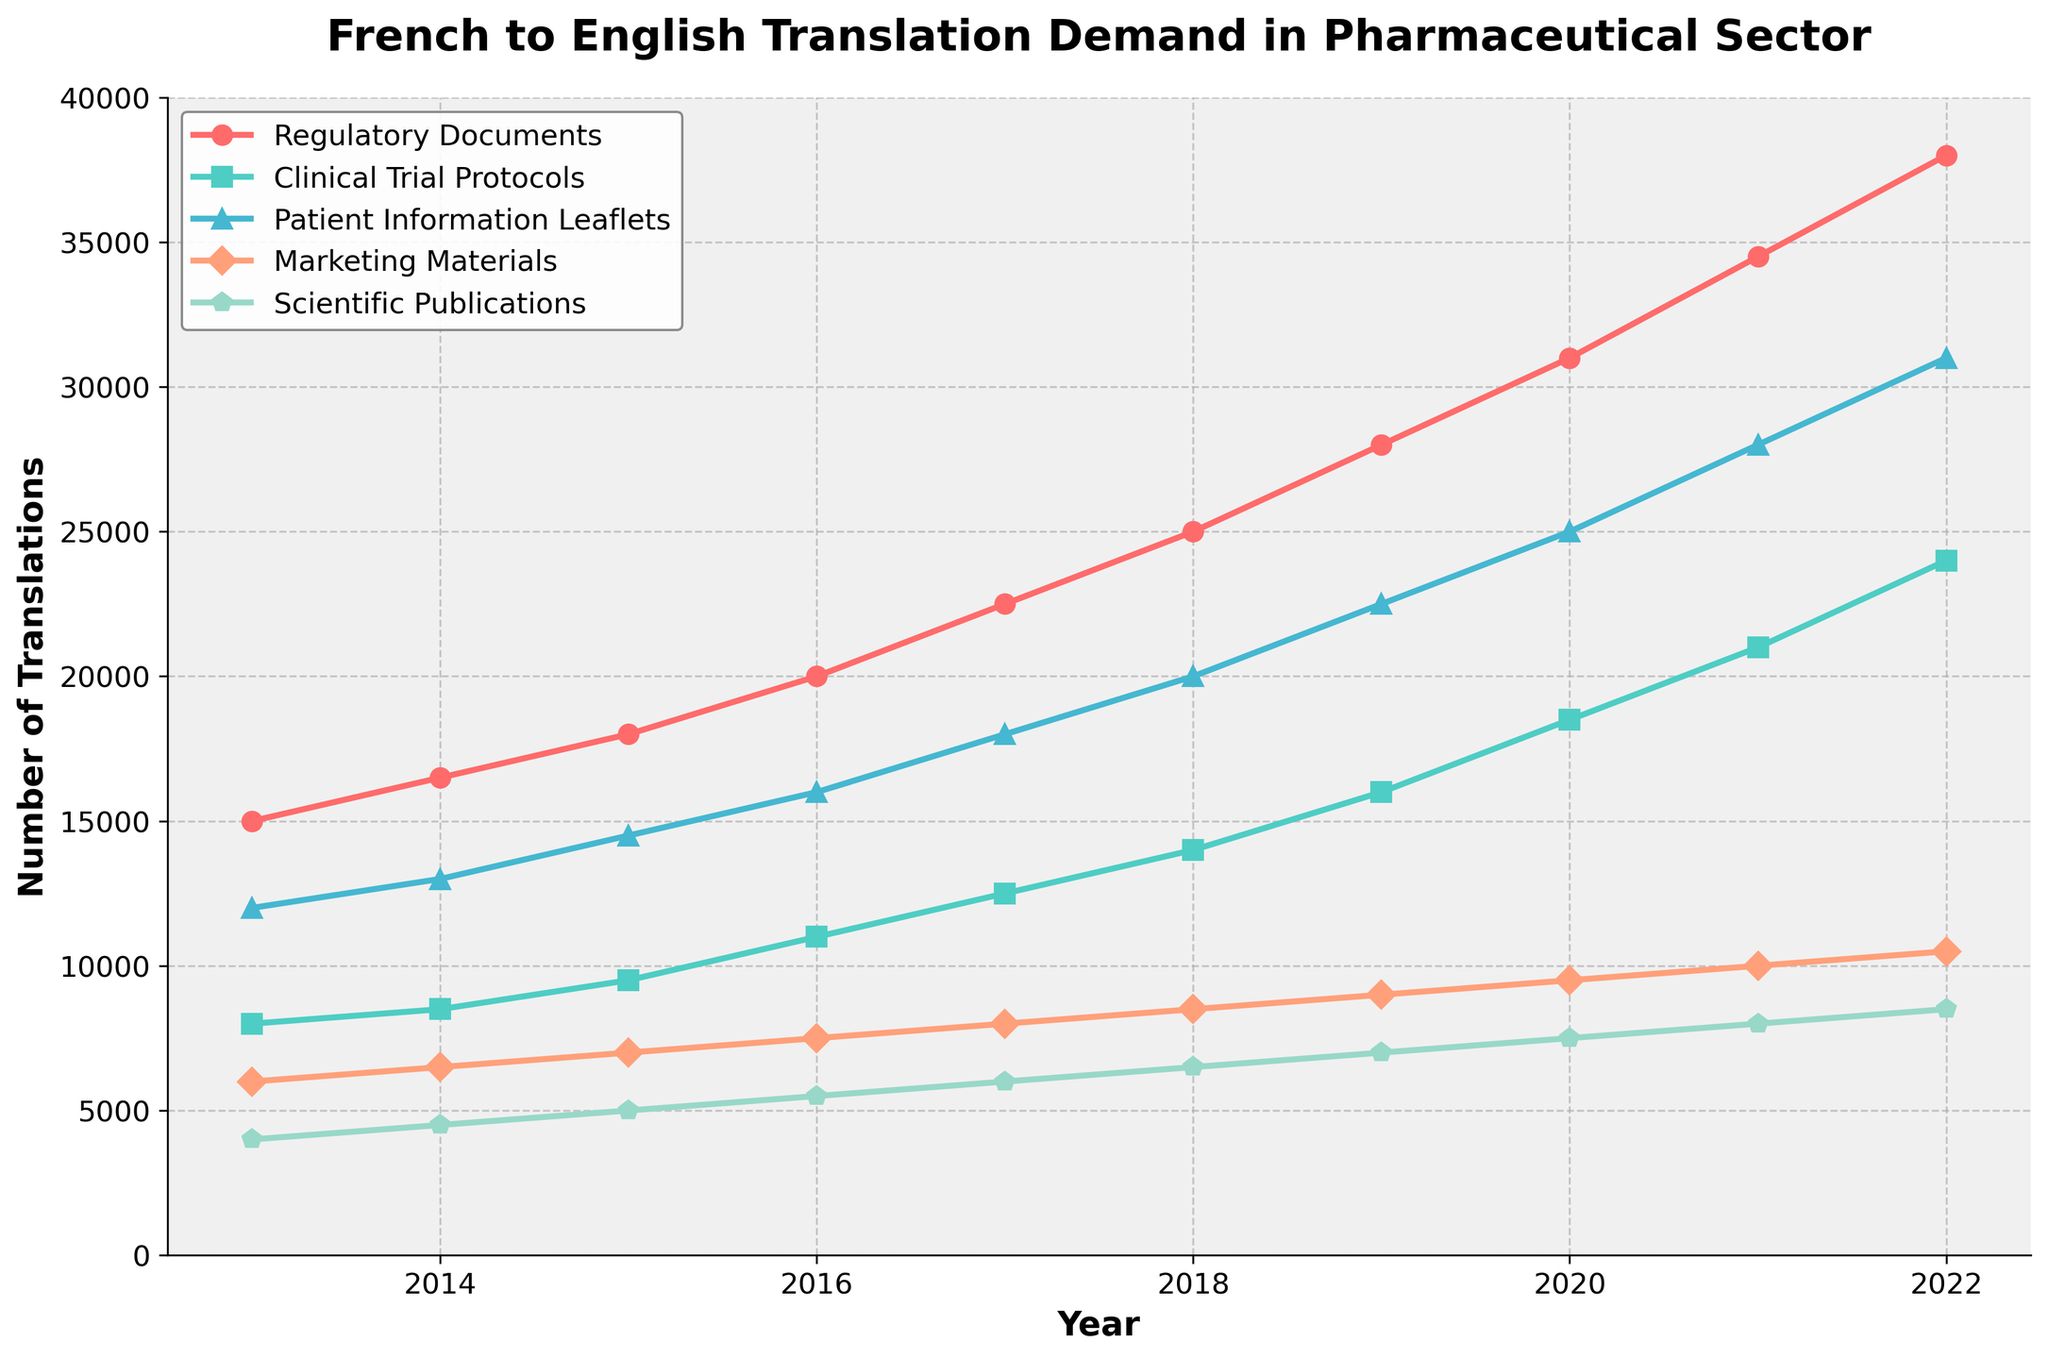What is the trend for Regulatory Documents translation demand from 2013 to 2022? Identify the line related to Regulatory Documents and observe its movement from 2013 to 2022. The demand increases steadily throughout the years, without any decline.
Answer: Steadily increasing In what year did Clinical Trial Protocols translation demand first surpass 15,000? Find the line for Clinical Trial Protocols and observe when it crosses the 15,000 mark. This happens in 2019.
Answer: 2019 Which document type showed the highest translation demand in 2022? Compare the endpoints of all lines at 2022. The line for Regulatory Documents is at the highest point.
Answer: Regulatory Documents What is the total translation demand for all document types in 2020? Sum the values of all document types for the year 2020. (31000 + 18500 + 25000 + 9500 + 7500) = 91500
Answer: 91,500 How does the demand for Marketing Materials translation compare with Scientific Publications in 2015? Check the respective lines at the year 2015. Marketing Materials's endpoint is higher at 7000 compared to Scientific Publications endpoint at 5000.
Answer: Marketing Materials higher By how much did the translation demand for Patient Information Leaflets increase between 2017 and 2020? Subtract the value at 2017 from the value at 2020 for Patient Information Leaflets (25000 - 18000) = 7000
Answer: 7,000 Which document type had the slowest growth in translation demand from 2013 to 2022? Compare the total increase from 2013 to 2022 for all document types. Scientific Publications had the slowest growth, increasing by 4500 (8500 - 4000).
Answer: Scientific Publications In what years did the Marketing Materials translation demand remain the same? Identify the line for Marketing Materials and observe years with flat segments. There are no flat segments in this line.
Answer: None What is the average translation demand for Clinical Trial Protocols over the decade? Add the annual values for Clinical Trial Protocols and divide by the number of years. (8000 + 8500 + 9500 + 11000 + 12500 + 14000 + 16000 + 18500 + 21000 + 24000) / 10 = 13400
Answer: 13,400 Between which consecutive years did Patient Information Leaflets experience the greatest increase in translation demand? Subtract the values for consecutive years and find the greatest difference: 
- 2014-2013: 13000 - 12000 = 1000
- 2015-2014: 14500 - 13000 = 1500
- 2016-2015: 16000 - 14500 = 1500
- 2017-2016: 18000 - 16000 = 2000
- 2018-2017: 20000 - 18000 = 2000
- 2019-2018: 22500 - 20000 = 2500
- 2020-2019: 25000 - 22500 = 2500
- 2021-2020: 28000 - 25000 = 3000
- 2022-2021: 31000 - 28000 = 3000
Patient Information Leaflets saw the greatest increase from 2021 to 2022 and 2020 to 2021, both 3000.
Answer: 2021 to 2022 and 2020 to 2021 